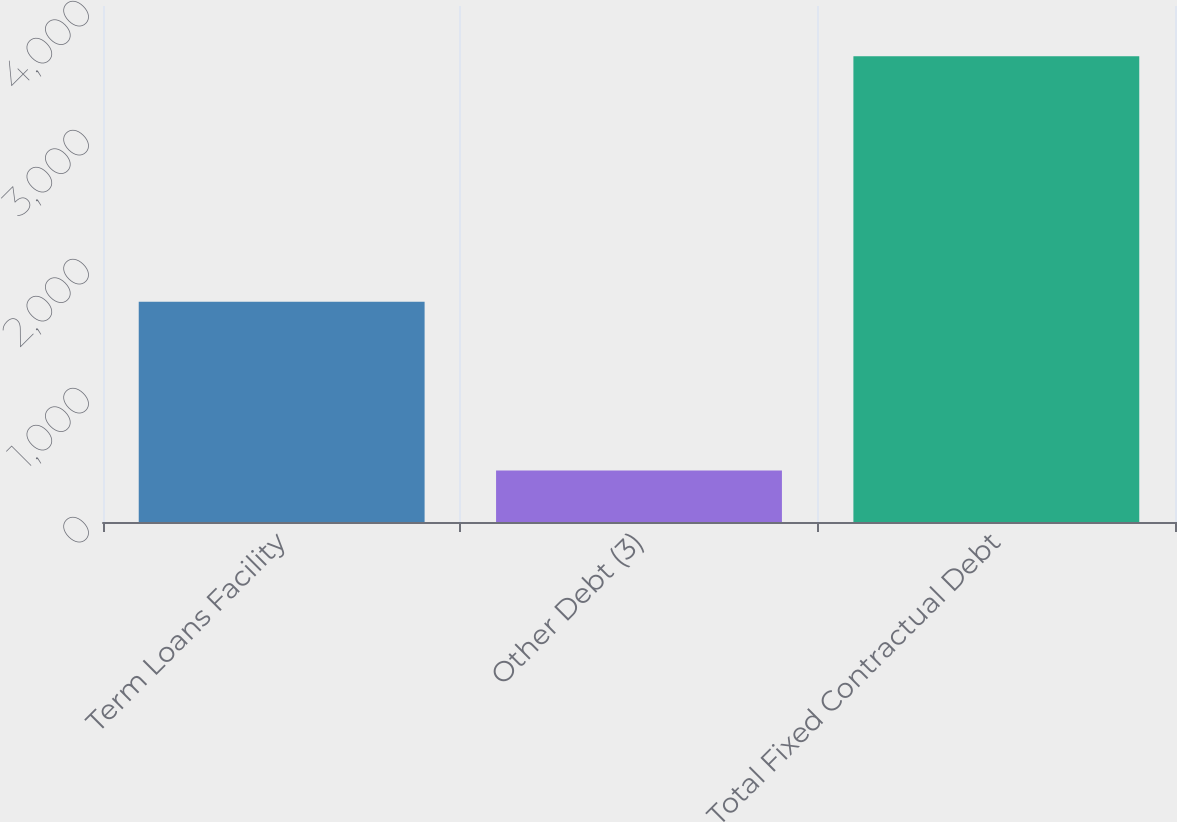Convert chart to OTSL. <chart><loc_0><loc_0><loc_500><loc_500><bar_chart><fcel>Term Loans Facility<fcel>Other Debt (3)<fcel>Total Fixed Contractual Debt<nl><fcel>1708<fcel>399<fcel>3611<nl></chart> 